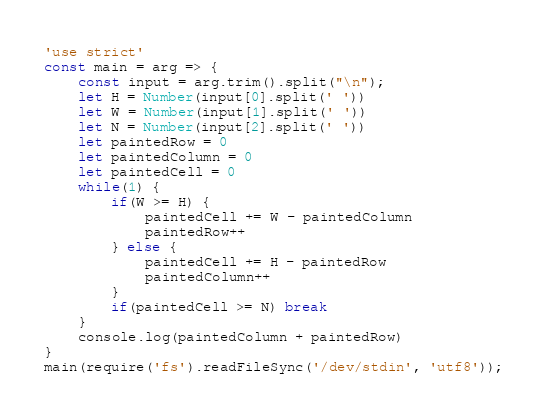Convert code to text. <code><loc_0><loc_0><loc_500><loc_500><_JavaScript_>'use strict'
const main = arg => {
	const input = arg.trim().split("\n");
	let H = Number(input[0].split(' '))
	let W = Number(input[1].split(' '))
	let N = Number(input[2].split(' '))
	let paintedRow = 0
	let paintedColumn = 0
	let paintedCell = 0
	while(1) {
		if(W >= H) {
			paintedCell += W - paintedColumn
			paintedRow++
		} else {
			paintedCell += H - paintedRow
			paintedColumn++
		}
		if(paintedCell >= N) break
	}
	console.log(paintedColumn + paintedRow)
}   
main(require('fs').readFileSync('/dev/stdin', 'utf8'));</code> 